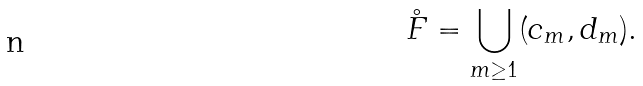<formula> <loc_0><loc_0><loc_500><loc_500>\mathring { F } = \bigcup _ { m \geq 1 } ( c _ { m } , d _ { m } ) .</formula> 